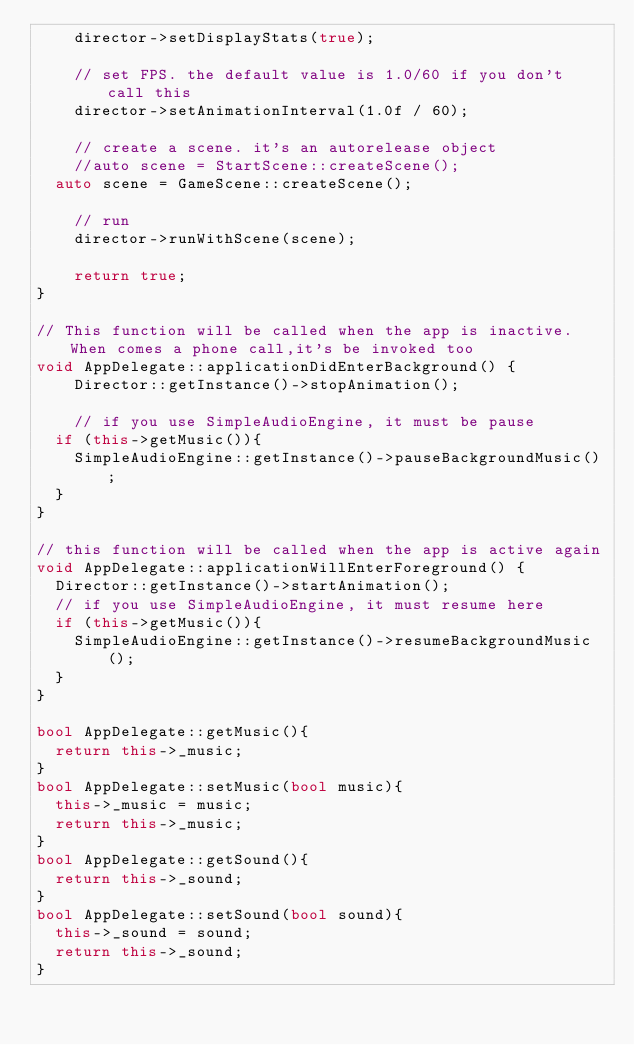Convert code to text. <code><loc_0><loc_0><loc_500><loc_500><_C++_>    director->setDisplayStats(true);

    // set FPS. the default value is 1.0/60 if you don't call this
    director->setAnimationInterval(1.0f / 60);

    // create a scene. it's an autorelease object
    //auto scene = StartScene::createScene();
	auto scene = GameScene::createScene();

    // run
    director->runWithScene(scene);

    return true;
}

// This function will be called when the app is inactive. When comes a phone call,it's be invoked too
void AppDelegate::applicationDidEnterBackground() {
    Director::getInstance()->stopAnimation();

    // if you use SimpleAudioEngine, it must be pause
	if (this->getMusic()){
		SimpleAudioEngine::getInstance()->pauseBackgroundMusic();
	}
}

// this function will be called when the app is active again
void AppDelegate::applicationWillEnterForeground() {
	Director::getInstance()->startAnimation();
	// if you use SimpleAudioEngine, it must resume here
	if (this->getMusic()){
		SimpleAudioEngine::getInstance()->resumeBackgroundMusic();
	}
}

bool AppDelegate::getMusic(){
	return this->_music;
}
bool AppDelegate::setMusic(bool music){
	this->_music = music;
	return this->_music;
}
bool AppDelegate::getSound(){
	return this->_sound;
}
bool AppDelegate::setSound(bool sound){
	this->_sound = sound;
	return this->_sound;
}</code> 